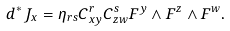Convert formula to latex. <formula><loc_0><loc_0><loc_500><loc_500>d ^ { * } \, J _ { x } = \eta _ { r s } C ^ { r } _ { x y } C ^ { s } _ { z w } F ^ { y } \wedge F ^ { z } \wedge F ^ { w } .</formula> 